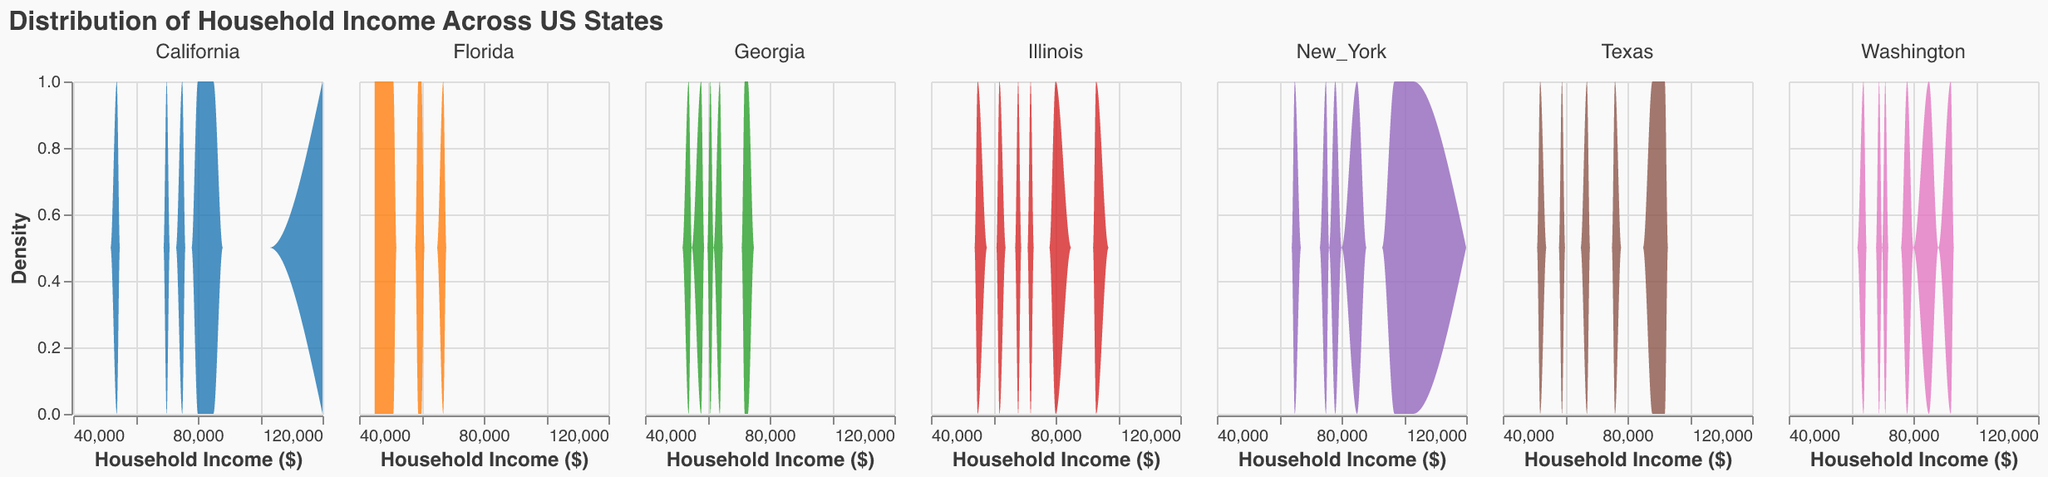What is the title of the figure? The title is displayed at the top of the figure. It reads "Distribution of Household Income Across US States".
Answer: Distribution of Household Income Across US States Which state has the widest range of household incomes visible in the figure? Examining the x-axes for all states, California has household incomes ranging from $54,000 to $120,000, which indicates the widest range.
Answer: California What is the household income range for Florida? The x-axis of Florida's subplot shows household incomes from $45,000 to $67,000.
Answer: $45,000 to $67,000 Does any state have a household income exceeding $100,000? If so, which one? By checking all subplots for values over $100,000 on the x-axis, only New York shows household incomes exceeding $100,000.
Answer: New York Which state appears to have the highest density in the $60,000-$70,000 household income range? By inspecting the density plot peaks around the $60,000-$70,000 range, Georgia shows the highest density.
Answer: Georgia Which states have household incomes less than $50,000? Looking at the x-axis for incomes under $50,000, only Florida includes household incomes less than $50,000.
Answer: Florida Compare the density peaks of Texas and Illinois for household incomes around $70,000. Which state has a higher density? By comparing the subplot peaks near $70,000, Illinois has a higher density peak than Texas in this range.
Answer: Illinois What is the approximate household income at the peak density for Washington? Observing the peak of Washington's density plot, the highest density occurs around an income of approximately $78,000.
Answer: $78,000 How many states show a household income density peak around $85,000? Checking each subplot, California, New York, Washington, and Illinois show peaks around $85,000.
Answer: Four states 